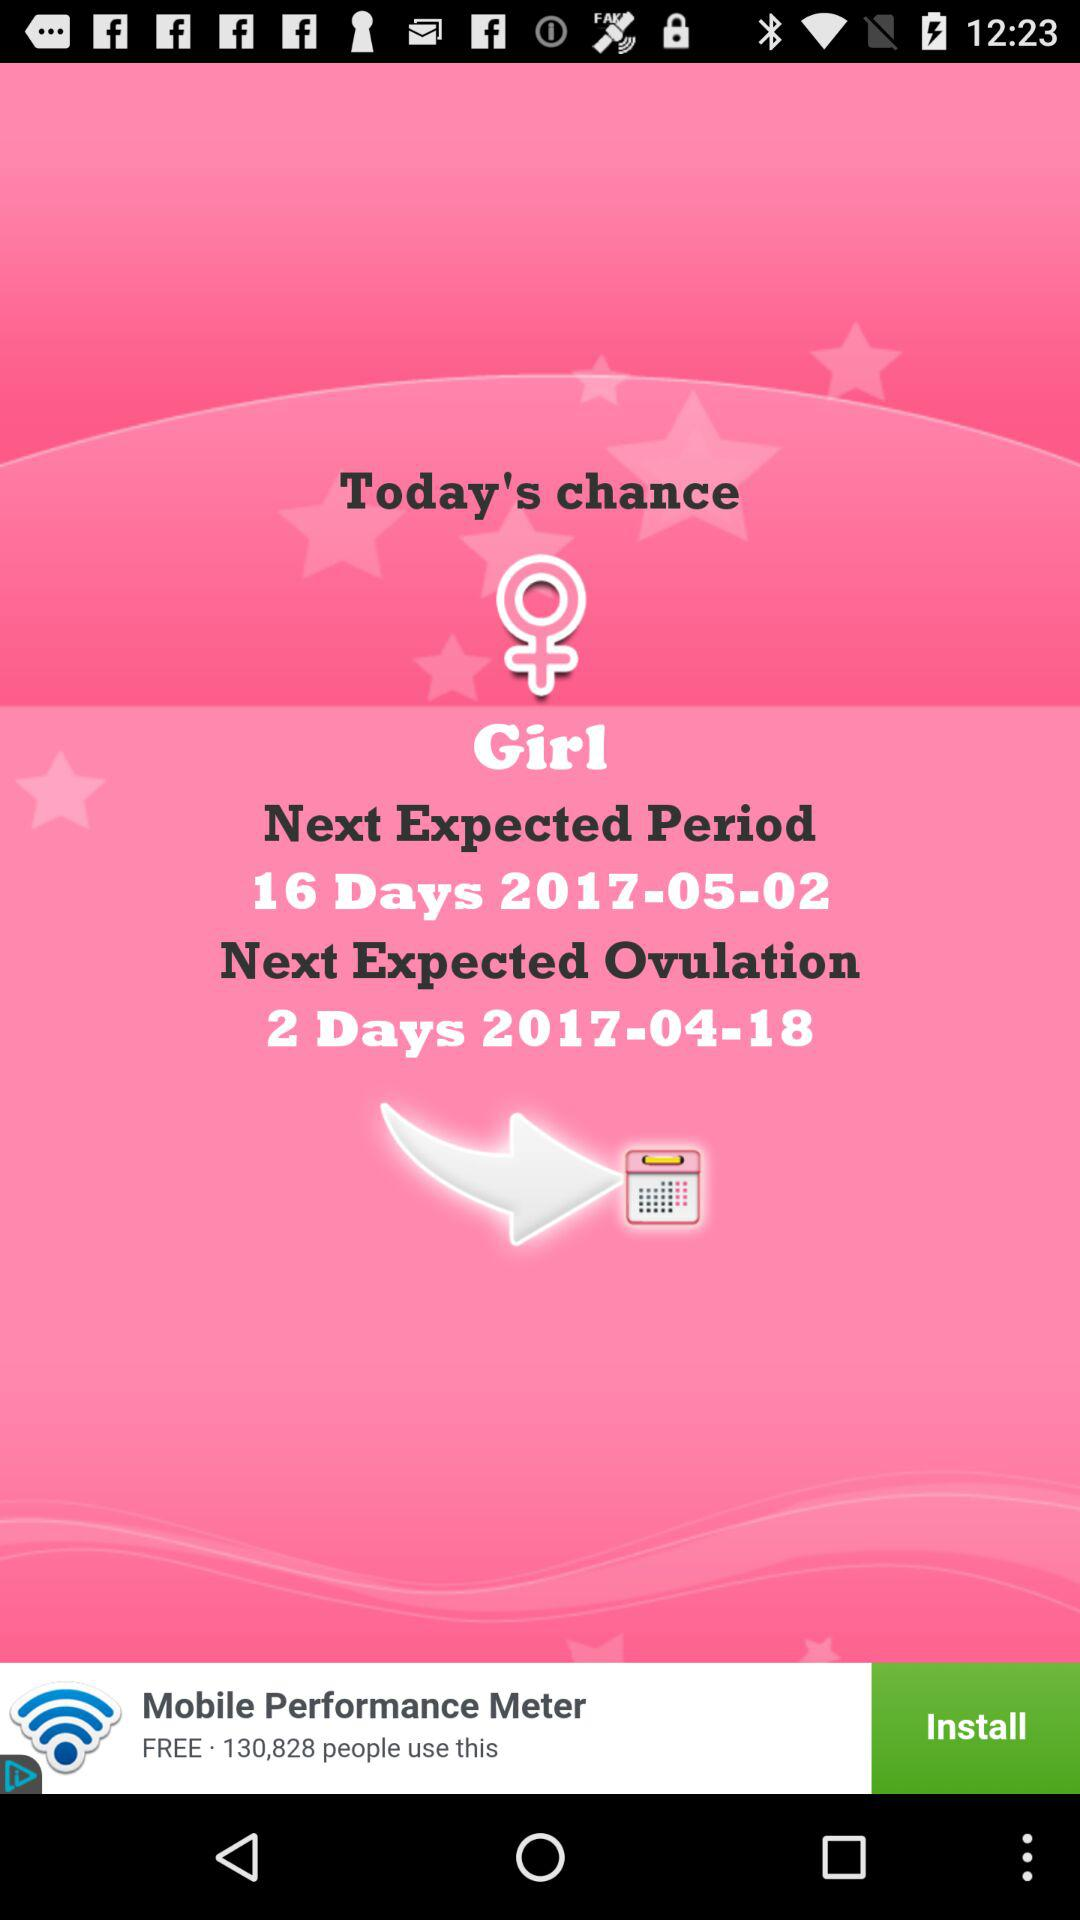When will the next expected period be? The next expected period will be on May 2, 2017. 